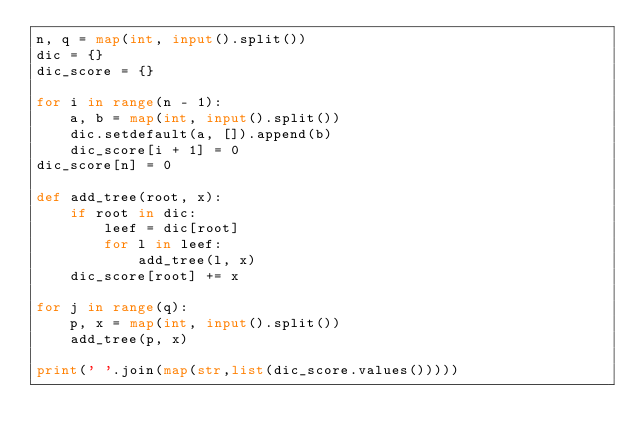Convert code to text. <code><loc_0><loc_0><loc_500><loc_500><_Python_>n, q = map(int, input().split())
dic = {}
dic_score = {}

for i in range(n - 1):
    a, b = map(int, input().split())
    dic.setdefault(a, []).append(b)
    dic_score[i + 1] = 0
dic_score[n] = 0

def add_tree(root, x):
    if root in dic:
        leef = dic[root]
        for l in leef:
            add_tree(l, x)
    dic_score[root] += x

for j in range(q):
    p, x = map(int, input().split())
    add_tree(p, x)

print(' '.join(map(str,list(dic_score.values()))))
      
</code> 